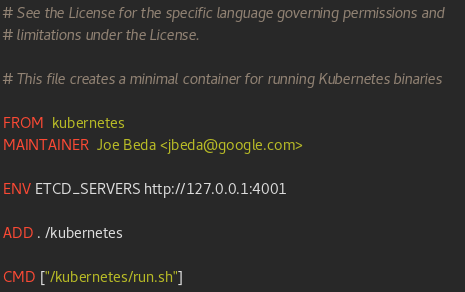<code> <loc_0><loc_0><loc_500><loc_500><_Dockerfile_># See the License for the specific language governing permissions and
# limitations under the License.

# This file creates a minimal container for running Kubernetes binaries

FROM  kubernetes
MAINTAINER  Joe Beda <jbeda@google.com>

ENV ETCD_SERVERS http://127.0.0.1:4001

ADD . /kubernetes

CMD ["/kubernetes/run.sh"]
</code> 